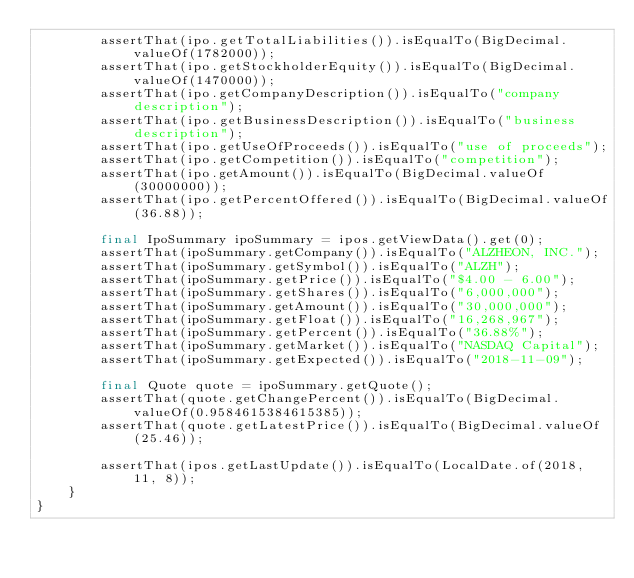<code> <loc_0><loc_0><loc_500><loc_500><_Java_>        assertThat(ipo.getTotalLiabilities()).isEqualTo(BigDecimal.valueOf(1782000));
        assertThat(ipo.getStockholderEquity()).isEqualTo(BigDecimal.valueOf(1470000));
        assertThat(ipo.getCompanyDescription()).isEqualTo("company description");
        assertThat(ipo.getBusinessDescription()).isEqualTo("business description");
        assertThat(ipo.getUseOfProceeds()).isEqualTo("use of proceeds");
        assertThat(ipo.getCompetition()).isEqualTo("competition");
        assertThat(ipo.getAmount()).isEqualTo(BigDecimal.valueOf(30000000));
        assertThat(ipo.getPercentOffered()).isEqualTo(BigDecimal.valueOf(36.88));

        final IpoSummary ipoSummary = ipos.getViewData().get(0);
        assertThat(ipoSummary.getCompany()).isEqualTo("ALZHEON, INC.");
        assertThat(ipoSummary.getSymbol()).isEqualTo("ALZH");
        assertThat(ipoSummary.getPrice()).isEqualTo("$4.00 - 6.00");
        assertThat(ipoSummary.getShares()).isEqualTo("6,000,000");
        assertThat(ipoSummary.getAmount()).isEqualTo("30,000,000");
        assertThat(ipoSummary.getFloat()).isEqualTo("16,268,967");
        assertThat(ipoSummary.getPercent()).isEqualTo("36.88%");
        assertThat(ipoSummary.getMarket()).isEqualTo("NASDAQ Capital");
        assertThat(ipoSummary.getExpected()).isEqualTo("2018-11-09");

        final Quote quote = ipoSummary.getQuote();
        assertThat(quote.getChangePercent()).isEqualTo(BigDecimal.valueOf(0.9584615384615385));
        assertThat(quote.getLatestPrice()).isEqualTo(BigDecimal.valueOf(25.46));

        assertThat(ipos.getLastUpdate()).isEqualTo(LocalDate.of(2018, 11, 8));
    }
}
</code> 